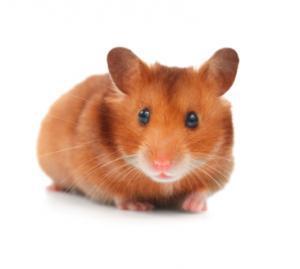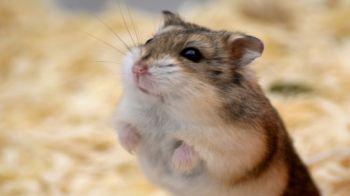The first image is the image on the left, the second image is the image on the right. Examine the images to the left and right. Is the description "In at least one of the images, the hamster is holding food" accurate? Answer yes or no. No. 